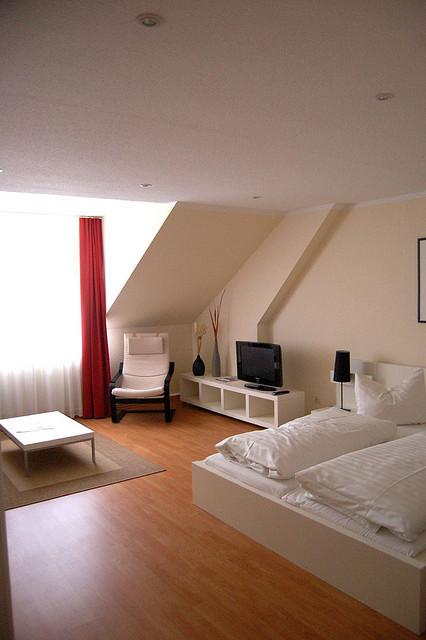How many watts does a night lamp use? Please explain your reasoning. 3-7.5. It depends on the type of bulb. 